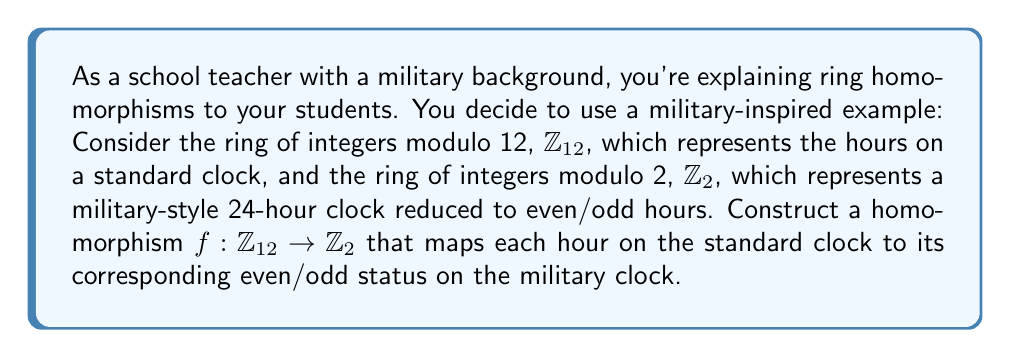Help me with this question. To construct a homomorphism $f: \mathbb{Z}_{12} \rightarrow \mathbb{Z}_2$, we need to define a function that preserves the ring operations (addition and multiplication) and maps the identity elements.

Let's define our function $f$ as follows:
$$f(x) = x \bmod 2$$

Now, let's verify that this is indeed a homomorphism:

1. Preservation of addition:
   For any $a, b \in \mathbb{Z}_{12}$,
   $$f(a + b) = (a + b) \bmod 2 = ((a \bmod 2) + (b \bmod 2)) \bmod 2 = f(a) + f(b)$$

2. Preservation of multiplication:
   For any $a, b \in \mathbb{Z}_{12}$,
   $$f(a \cdot b) = (a \cdot b) \bmod 2 = ((a \bmod 2) \cdot (b \bmod 2)) \bmod 2 = f(a) \cdot f(b)$$

3. Mapping of identity elements:
   The additive identity in $\mathbb{Z}_{12}$ is 0, and in $\mathbb{Z}_2$ is also 0.
   $$f(0) = 0 \bmod 2 = 0$$

Therefore, $f$ is a valid homomorphism from $\mathbb{Z}_{12}$ to $\mathbb{Z}_2$.

In the context of our clock example:
- Even hours (0, 2, 4, 6, 8, 10) in $\mathbb{Z}_{12}$ map to 0 in $\mathbb{Z}_2$
- Odd hours (1, 3, 5, 7, 9, 11) in $\mathbb{Z}_{12}$ map to 1 in $\mathbb{Z}_2$

This homomorphism effectively groups the hours into even and odd categories, which aligns with the military's practice of using a 24-hour clock system.
Answer: The homomorphism $f: \mathbb{Z}_{12} \rightarrow \mathbb{Z}_2$ is defined by $f(x) = x \bmod 2$. 